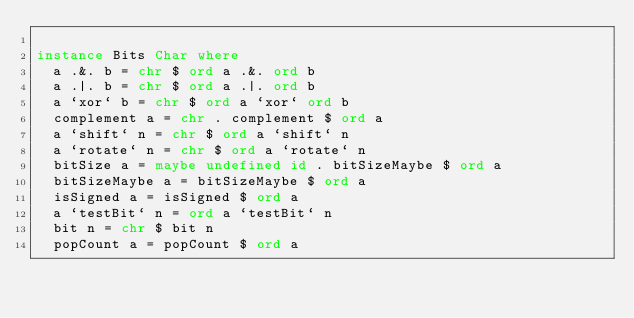<code> <loc_0><loc_0><loc_500><loc_500><_Haskell_>
instance Bits Char where
  a .&. b = chr $ ord a .&. ord b
  a .|. b = chr $ ord a .|. ord b
  a `xor` b = chr $ ord a `xor` ord b
  complement a = chr . complement $ ord a 
  a `shift` n = chr $ ord a `shift` n
  a `rotate` n = chr $ ord a `rotate` n
  bitSize a = maybe undefined id . bitSizeMaybe $ ord a 
  bitSizeMaybe a = bitSizeMaybe $ ord a
  isSigned a = isSigned $ ord a
  a `testBit` n = ord a `testBit` n
  bit n = chr $ bit n
  popCount a = popCount $ ord a
</code> 